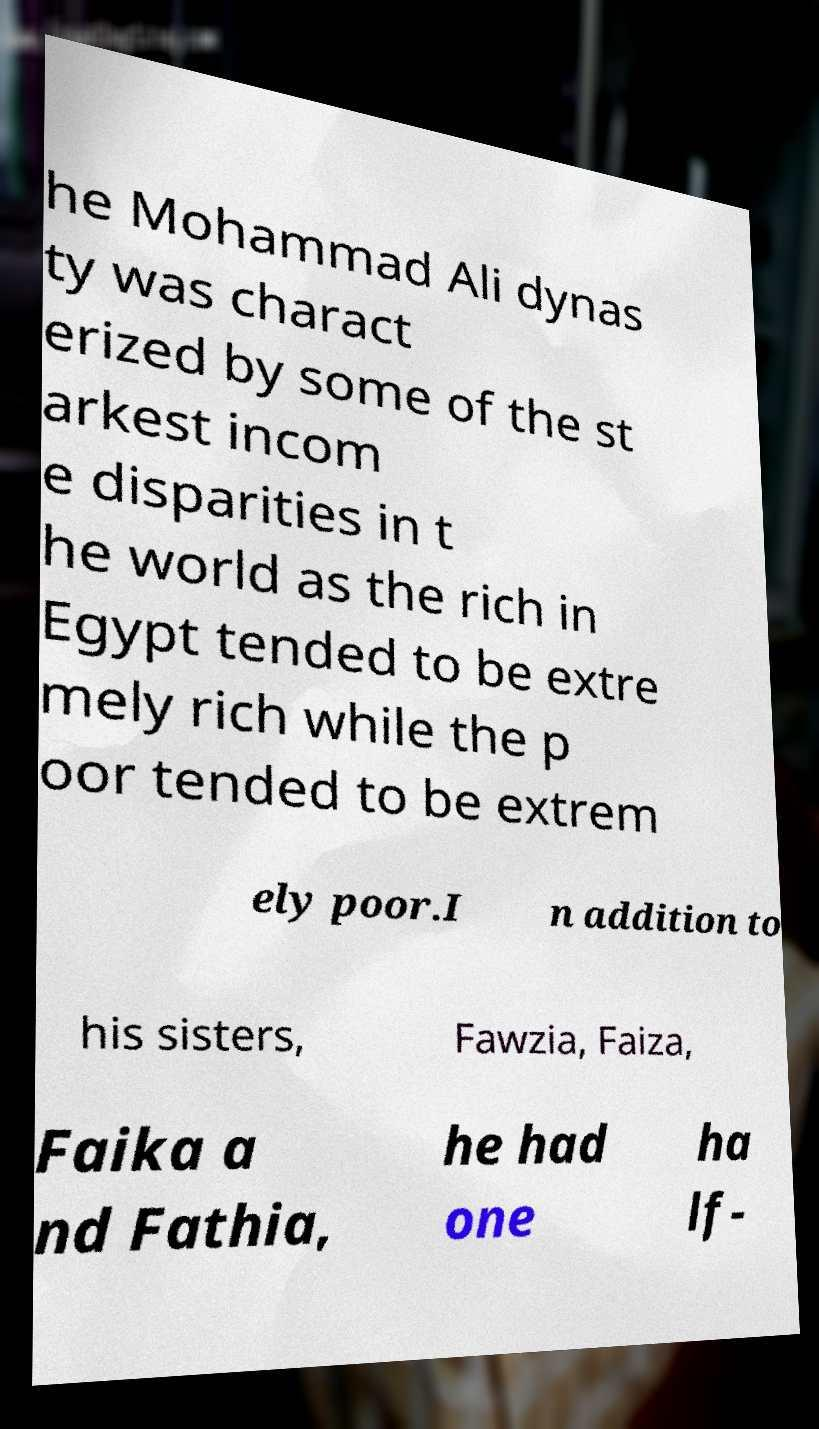Can you accurately transcribe the text from the provided image for me? he Mohammad Ali dynas ty was charact erized by some of the st arkest incom e disparities in t he world as the rich in Egypt tended to be extre mely rich while the p oor tended to be extrem ely poor.I n addition to his sisters, Fawzia, Faiza, Faika a nd Fathia, he had one ha lf- 